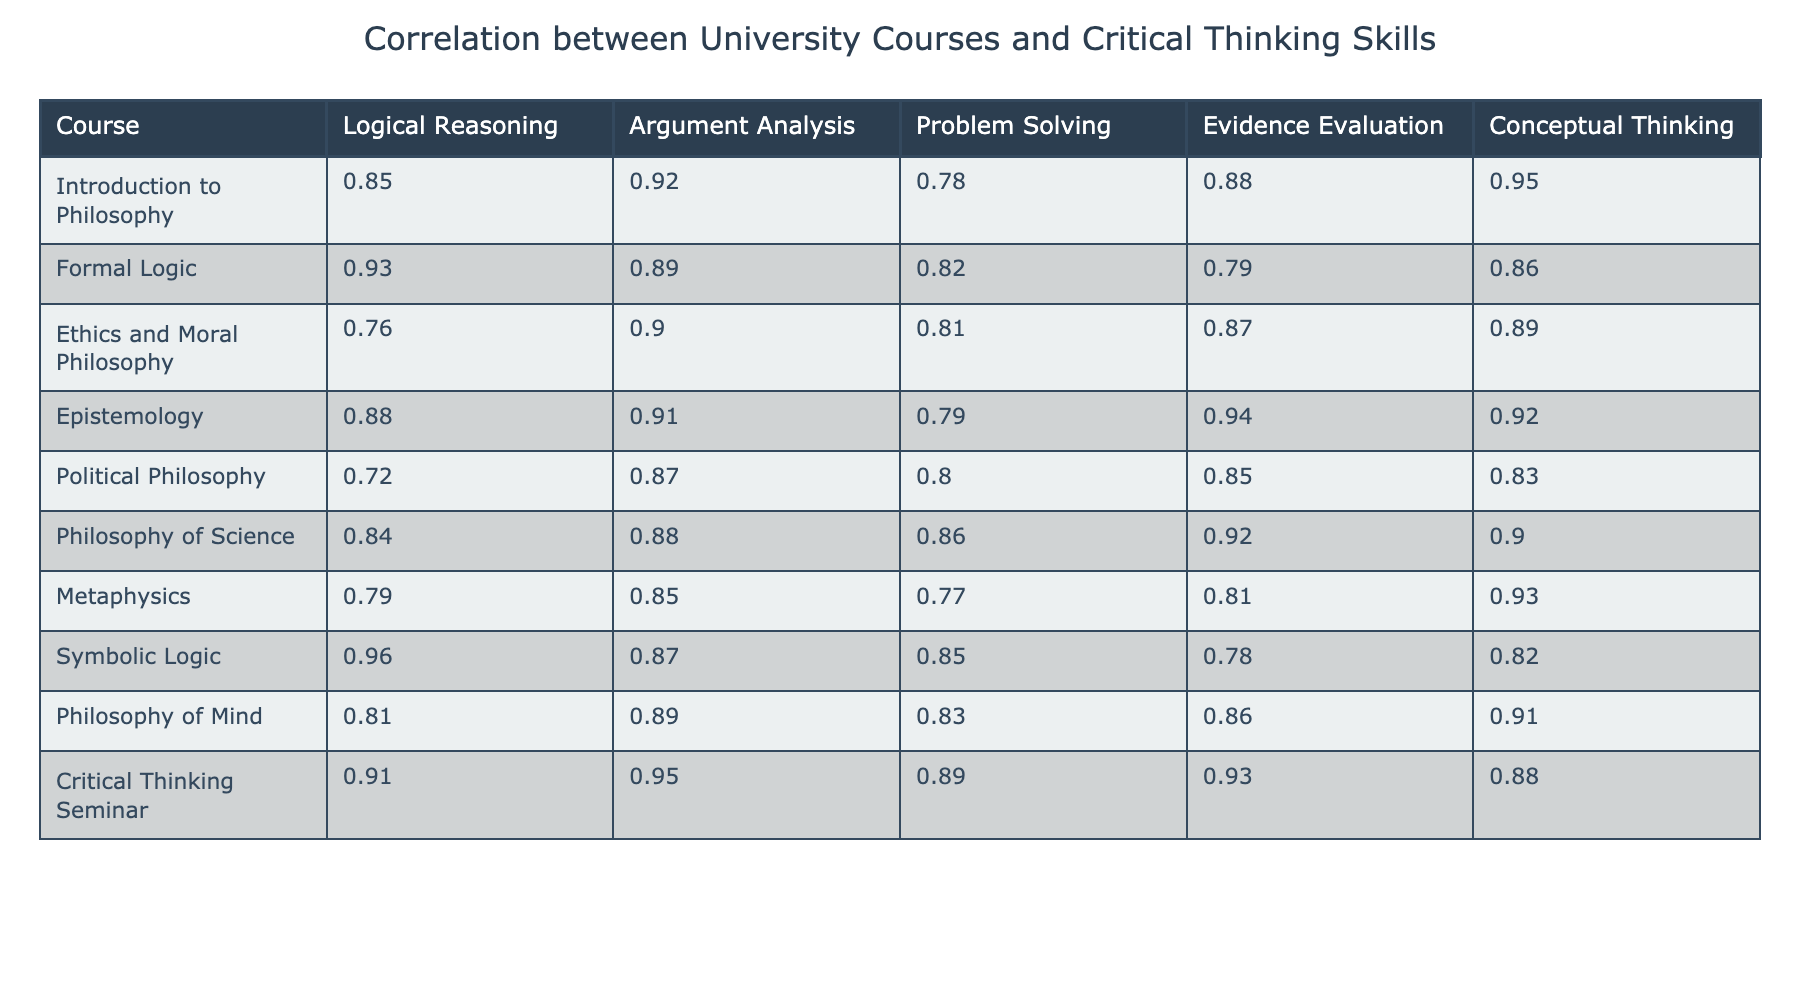What is the correlation value for Logical Reasoning in the Introduction to Philosophy course? The table indicates that the correlation value for Logical Reasoning in the Introduction to Philosophy course is 0.85.
Answer: 0.85 Which course has the highest correlation value for Evidence Evaluation? By examining the table, the course that has the highest correlation value for Evidence Evaluation is Epistemology, with a value of 0.94.
Answer: Epistemology What is the average correlation value for Conceptual Thinking across all courses? To calculate the average correlation value for Conceptual Thinking, we add the values (0.95 + 0.86 + 0.89 + 0.92 + 0.83 + 0.90 + 0.93 + 0.82 + 0.91 + 0.88) = 8.85 and then divide by the number of courses, which is 10. Thus, the average is 8.85/10 = 0.885.
Answer: 0.885 Is there any course that has a correlation value of 0.80 or lower for Argument Analysis? By reviewing the table, Political Philosophy has the lowest correlation value for Argument Analysis at 0.87, which means there is no course with a correlation value of 0.80 or lower for this skill.
Answer: No What is the relationship between Formal Logic and Problem Solving based on their correlation values? The table shows that Formal Logic has a correlation value of 0.82 for Problem Solving, which is lower than its correlation for Logical Reasoning (0.93) and indicates a weaker relationship in this area compared to other skills.
Answer: Weaker relationship What are the top three courses in terms of overall correlation across all critical thinking skills? To find the top three courses, we sum the correlation values for each course:
- Introduction to Philosophy: 0.85 + 0.92 + 0.78 + 0.88 + 0.95 = 4.38
- Formal Logic: 0.93 + 0.89 + 0.82 + 0.79 + 0.86 = 4.29
- Ethics and Moral Philosophy: 0.76 + 0.90 + 0.81 + 0.87 + 0.89 = 4.23
The top three courses based on these sums are Introduction to Philosophy, Formal Logic, and Ethics and Moral Philosophy.
Answer: Introduction to Philosophy, Formal Logic, Ethics and Moral Philosophy Which course shows the most balanced performance across all five critical thinking skills? By calculating the range between the highest and lowest correlation values for each course, Philosophy of Science exhibits values (0.84, 0.88, 0.86, 0.92, 0.90) with a range of 0.08, indicating more balance compared to others.
Answer: Philosophy of Science What is the difference in correlation value between the highest and lowest scores for Logical Reasoning across all courses? The highest score for Logical Reasoning is 0.96 (Symbolic Logic), and the lowest is 0.72 (Political Philosophy). Therefore, the difference is 0.96 - 0.72 = 0.24.
Answer: 0.24 